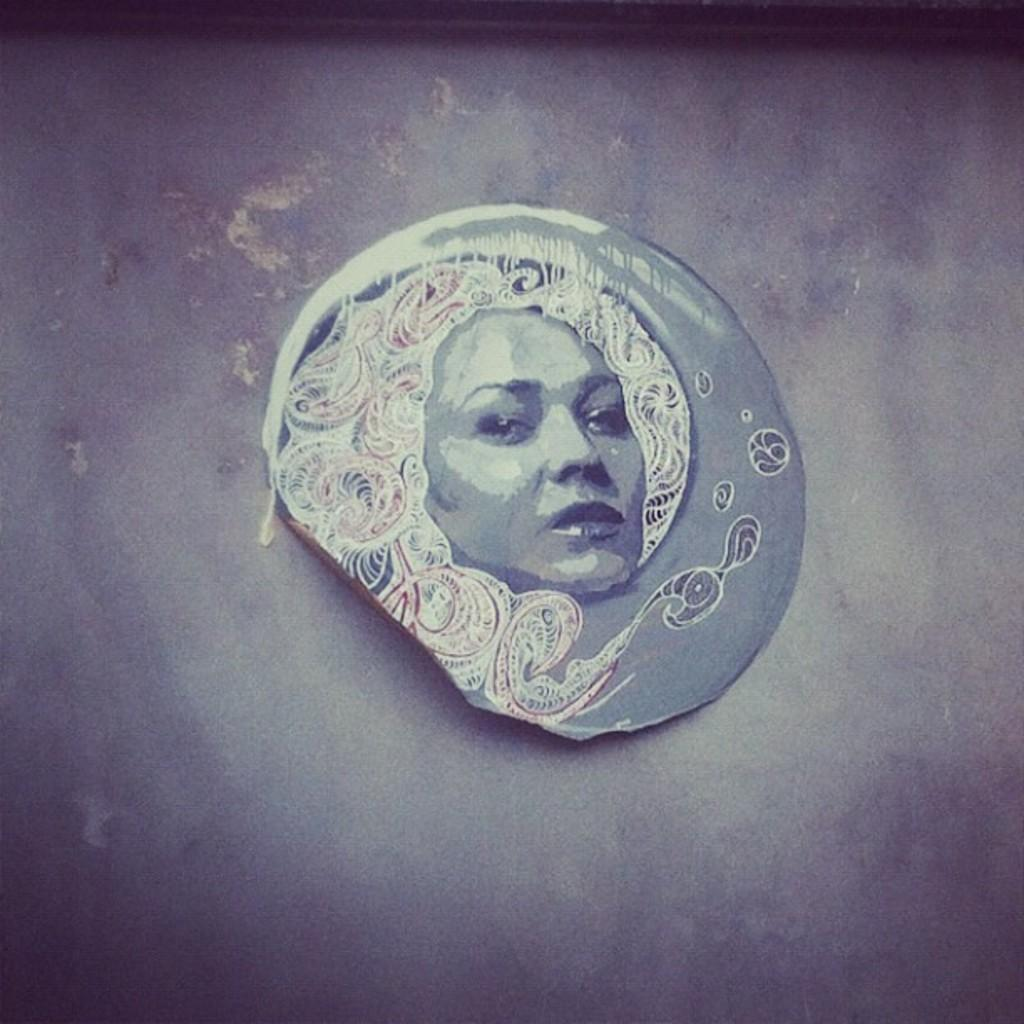What is the main subject in the middle of the image? There is an object in the middle of the image. Where is the object located? The object is on the floor. What can be seen on the object? There is a depiction of a person on the object. How many balls are visible in the image? There are no balls present in the image. What type of toys can be seen in the image? There are no toys visible in the image. 